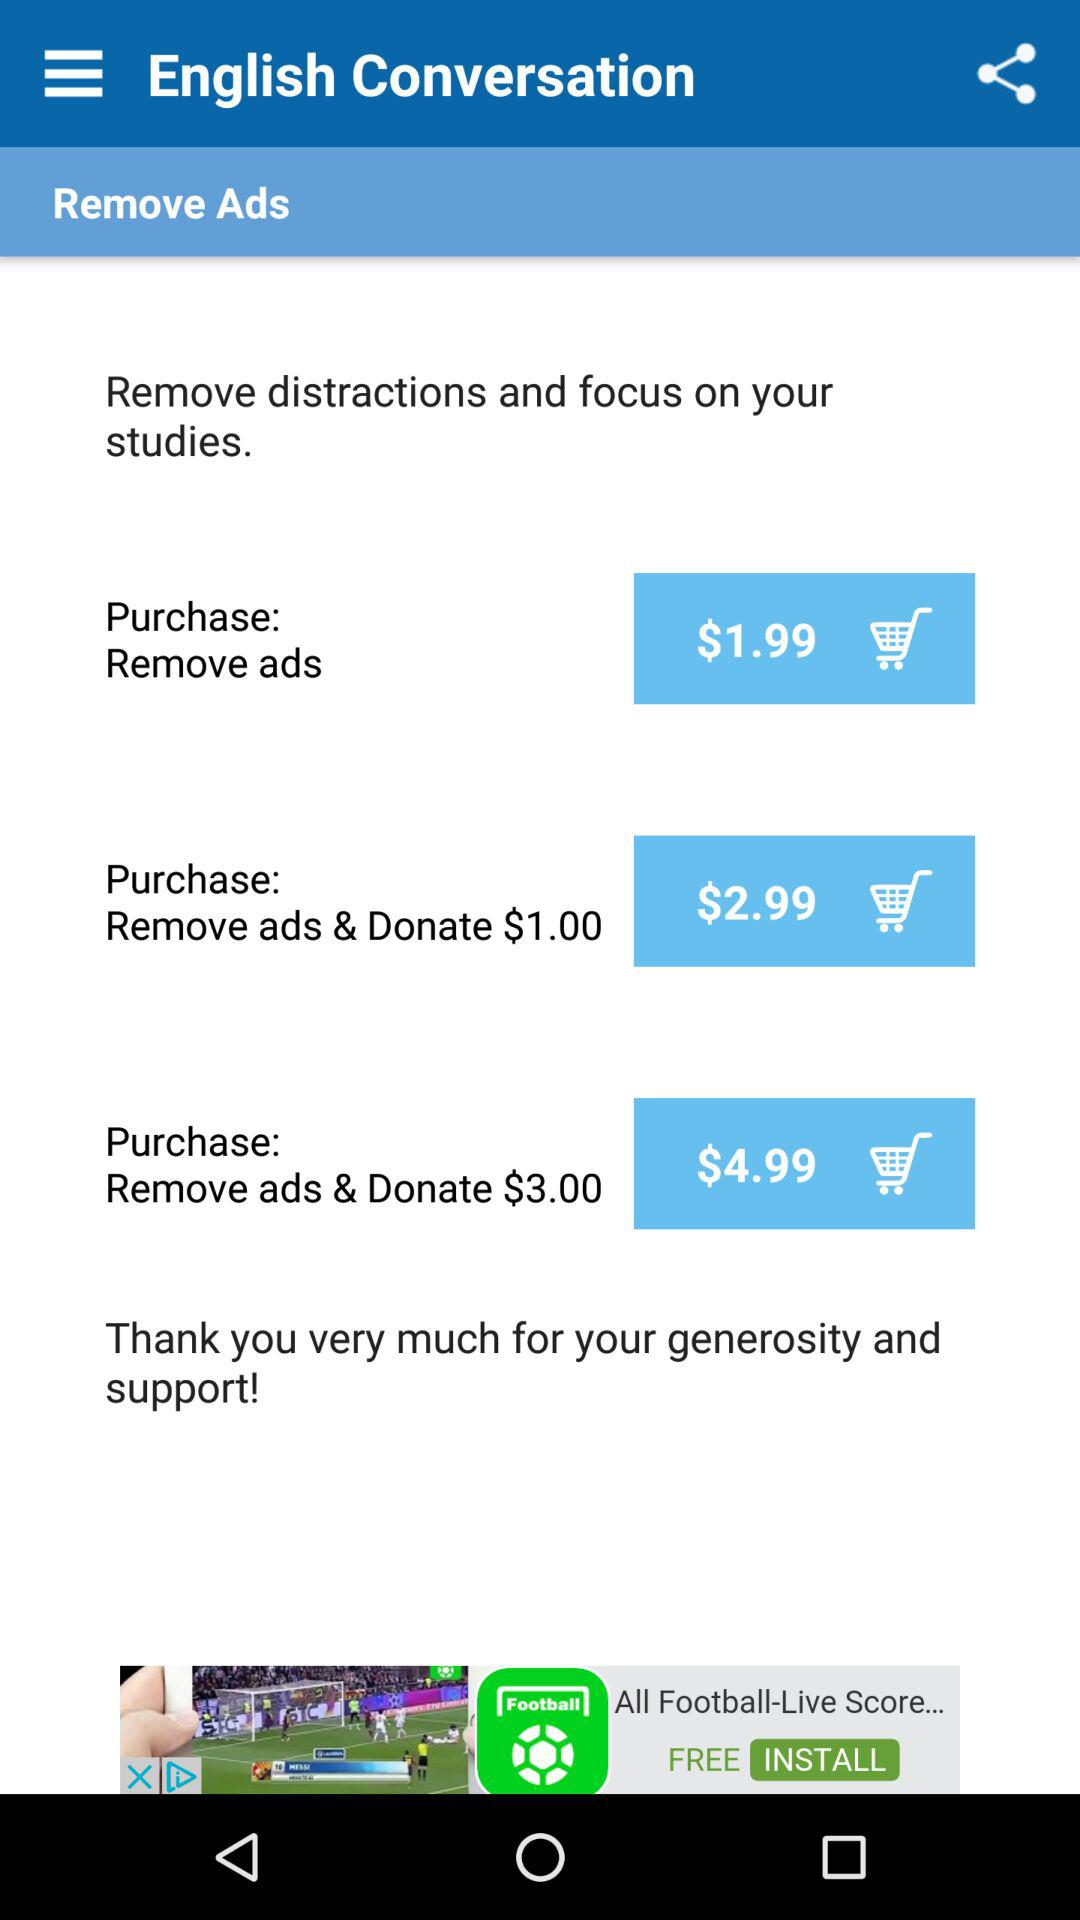What is the price of "Remove ads & Donate $1.00"? The price is $2.99. 